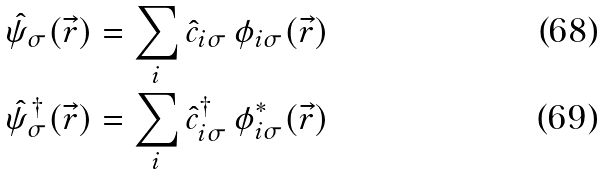Convert formula to latex. <formula><loc_0><loc_0><loc_500><loc_500>\hat { \psi } _ { \sigma } ( \vec { r } ) & = \sum _ { i } \hat { c } _ { i \sigma } \, \phi _ { i \sigma } ( \vec { r } ) \\ \hat { \psi } _ { \sigma } ^ { \dagger } ( \vec { r } ) & = \sum _ { i } \hat { c } ^ { \dagger } _ { i \sigma } \, \phi _ { i \sigma } ^ { * } ( \vec { r } )</formula> 